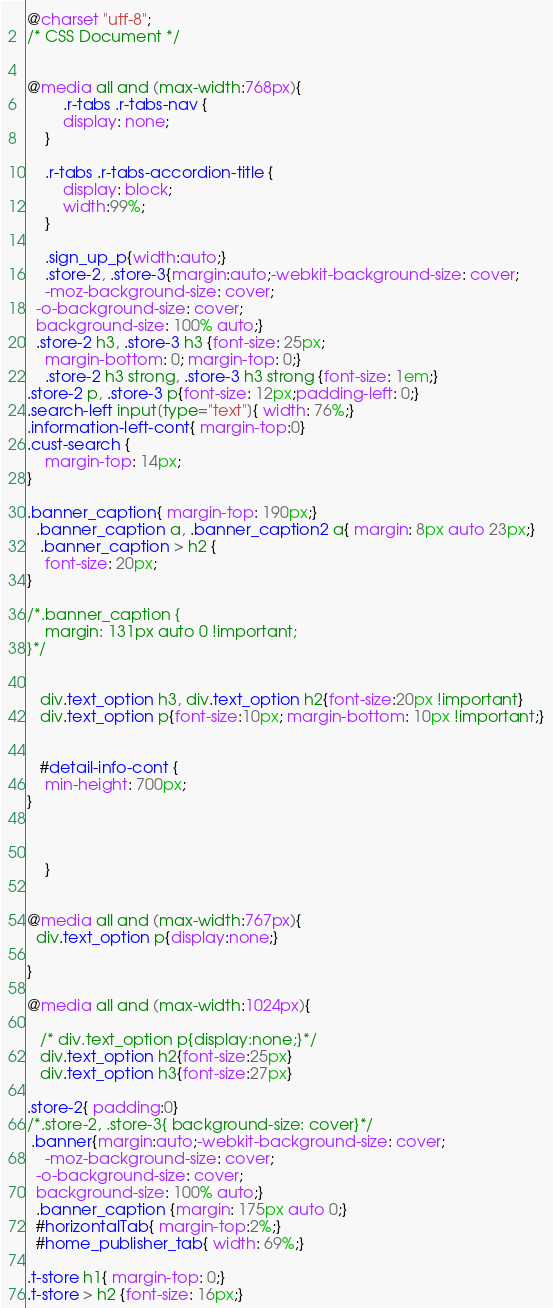<code> <loc_0><loc_0><loc_500><loc_500><_CSS_>@charset "utf-8";
/* CSS Document */


@media all and (max-width:768px){
	    .r-tabs .r-tabs-nav {
        display: none;
    }

    .r-tabs .r-tabs-accordion-title {
        display: block;
		width:99%;
    }
	
	.sign_up_p{width:auto;}
	.store-2, .store-3{margin:auto;-webkit-background-size: cover;
	-moz-background-size: cover;
  -o-background-size: cover;
  background-size: 100% auto;}
  .store-2 h3, .store-3 h3 {font-size: 25px;
    margin-bottom: 0; margin-top: 0;}
	.store-2 h3 strong, .store-3 h3 strong {font-size: 1em;}
.store-2 p, .store-3 p{font-size: 12px;padding-left: 0;}
.search-left input[type="text"]{ width: 76%;}	
.information-left-cont{ margin-top:0}
.cust-search {
    margin-top: 14px;
}

.banner_caption{ margin-top: 190px;}
  .banner_caption a, .banner_caption2 a{ margin: 8px auto 23px;}
   .banner_caption > h2 {
    font-size: 20px;
}

/*.banner_caption {
    margin: 131px auto 0 !important;
}*/


   div.text_option h3, div.text_option h2{font-size:20px !important}
   div.text_option p{font-size:10px; margin-bottom: 10px !important;}
   
   
   #detail-info-cont {
    min-height: 700px;
}   


    
	}


@media all and (max-width:767px){
  div.text_option p{display:none;}  
    
}
	
@media all and (max-width:1024px){
    
   /* div.text_option p{display:none;}*/
   div.text_option h2{font-size:25px}
   div.text_option h3{font-size:27px}
   
.store-2{ padding:0}
/*.store-2, .store-3{ background-size: cover}*/
 .banner{margin:auto;-webkit-background-size: cover;
	-moz-background-size: cover;
  -o-background-size: cover;
  background-size: 100% auto;}
  .banner_caption {margin: 175px auto 0;}
  #horizontalTab{ margin-top:2%;}
  #home_publisher_tab{ width: 69%;} 
  
.t-store h1{ margin-top: 0;}
.t-store > h2 {font-size: 16px;}</code> 